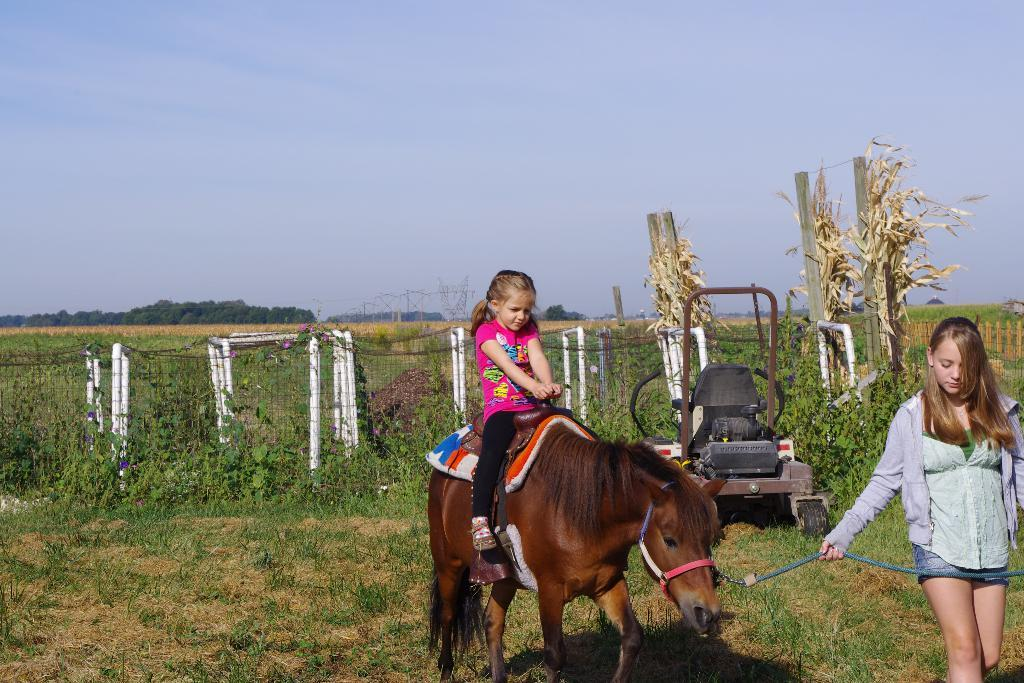What is the person in the image doing with the animal? There is a person sitting on an animal in the image. What is the other person holding in the image? Another person is holding a rope in the image. What type of natural environment can be seen in the image? There are trees and grass visible in the image. What type of transportation is present in the image? There is a vehicle in the image. What is visible in the background of the image? The sky is visible in the image. What type of barrier is present in the image? There is fencing in the image. What type of wax can be seen melting on the person's face in the image? There is no wax present in the image; it features a person sitting on an animal and another person holding a rope. How many birds are visible in the image? There are no birds visible in the image. 